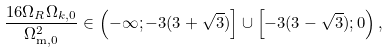Convert formula to latex. <formula><loc_0><loc_0><loc_500><loc_500>\frac { 1 6 \Omega _ { R } \Omega _ { k , 0 } } { \Omega _ { \text {m} , 0 } ^ { 2 } } \in \left ( - \infty ; - 3 ( 3 + \sqrt { 3 } ) \right ] \cup \left [ - 3 ( 3 - \sqrt { 3 } ) ; 0 \right ) ,</formula> 